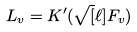Convert formula to latex. <formula><loc_0><loc_0><loc_500><loc_500>L _ { v } = K ^ { \prime } ( \sqrt { [ } \ell ] { F _ { v } } )</formula> 